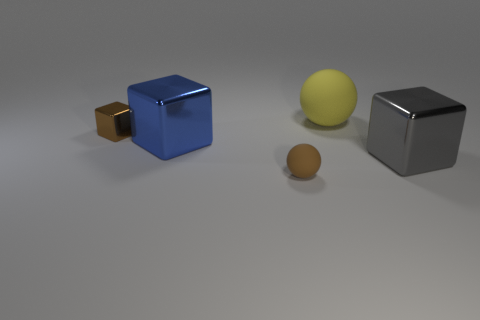Subtract all tiny brown cubes. How many cubes are left? 2 Add 4 small blue matte objects. How many objects exist? 9 Subtract all yellow balls. How many balls are left? 1 Add 3 gray shiny objects. How many gray shiny objects are left? 4 Add 1 brown rubber spheres. How many brown rubber spheres exist? 2 Subtract 0 cyan balls. How many objects are left? 5 Subtract all blocks. How many objects are left? 2 Subtract 1 balls. How many balls are left? 1 Subtract all purple balls. Subtract all yellow blocks. How many balls are left? 2 Subtract all blue cubes. How many yellow spheres are left? 1 